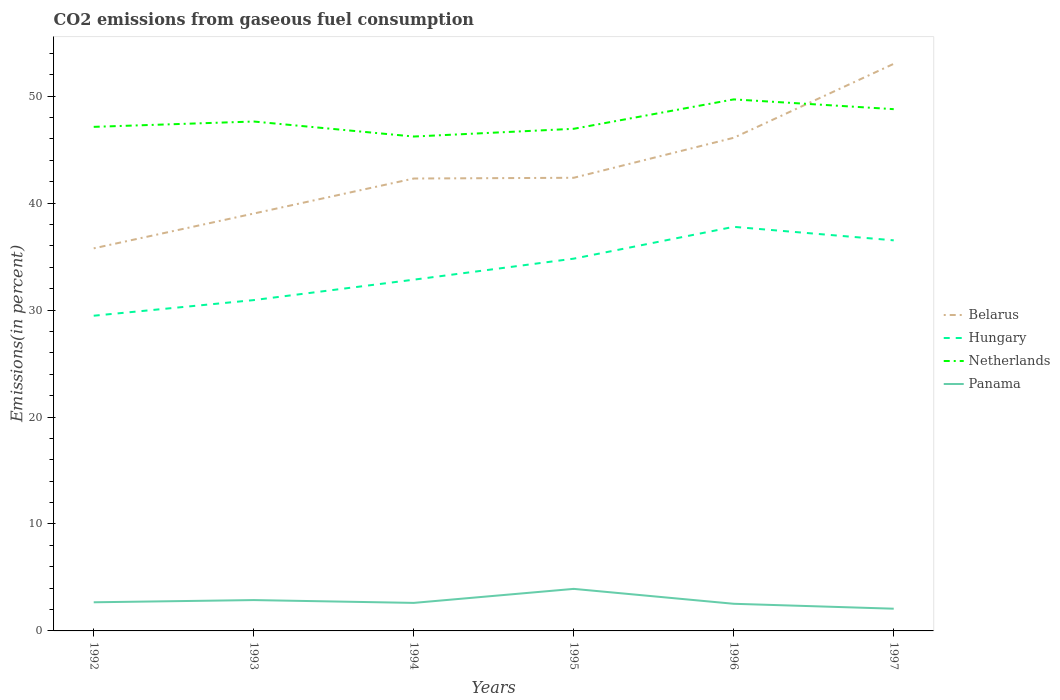How many different coloured lines are there?
Provide a short and direct response. 4. Is the number of lines equal to the number of legend labels?
Ensure brevity in your answer.  Yes. Across all years, what is the maximum total CO2 emitted in Panama?
Ensure brevity in your answer.  2.08. What is the total total CO2 emitted in Hungary in the graph?
Offer a terse response. -2.98. What is the difference between the highest and the second highest total CO2 emitted in Netherlands?
Your answer should be compact. 3.47. How many lines are there?
Keep it short and to the point. 4. What is the title of the graph?
Make the answer very short. CO2 emissions from gaseous fuel consumption. Does "Niger" appear as one of the legend labels in the graph?
Your answer should be very brief. No. What is the label or title of the X-axis?
Offer a very short reply. Years. What is the label or title of the Y-axis?
Offer a terse response. Emissions(in percent). What is the Emissions(in percent) in Belarus in 1992?
Offer a very short reply. 35.77. What is the Emissions(in percent) in Hungary in 1992?
Provide a short and direct response. 29.47. What is the Emissions(in percent) of Netherlands in 1992?
Your answer should be very brief. 47.13. What is the Emissions(in percent) in Panama in 1992?
Provide a succinct answer. 2.68. What is the Emissions(in percent) in Belarus in 1993?
Give a very brief answer. 39.02. What is the Emissions(in percent) of Hungary in 1993?
Make the answer very short. 30.93. What is the Emissions(in percent) of Netherlands in 1993?
Provide a succinct answer. 47.63. What is the Emissions(in percent) of Panama in 1993?
Your answer should be very brief. 2.88. What is the Emissions(in percent) in Belarus in 1994?
Ensure brevity in your answer.  42.3. What is the Emissions(in percent) of Hungary in 1994?
Give a very brief answer. 32.84. What is the Emissions(in percent) in Netherlands in 1994?
Make the answer very short. 46.22. What is the Emissions(in percent) in Panama in 1994?
Give a very brief answer. 2.62. What is the Emissions(in percent) in Belarus in 1995?
Your response must be concise. 42.37. What is the Emissions(in percent) in Hungary in 1995?
Offer a terse response. 34.81. What is the Emissions(in percent) of Netherlands in 1995?
Provide a short and direct response. 46.95. What is the Emissions(in percent) of Panama in 1995?
Make the answer very short. 3.93. What is the Emissions(in percent) in Belarus in 1996?
Give a very brief answer. 46.11. What is the Emissions(in percent) of Hungary in 1996?
Offer a terse response. 37.78. What is the Emissions(in percent) in Netherlands in 1996?
Keep it short and to the point. 49.7. What is the Emissions(in percent) of Panama in 1996?
Keep it short and to the point. 2.54. What is the Emissions(in percent) in Belarus in 1997?
Keep it short and to the point. 53.02. What is the Emissions(in percent) of Hungary in 1997?
Offer a terse response. 36.52. What is the Emissions(in percent) of Netherlands in 1997?
Ensure brevity in your answer.  48.78. What is the Emissions(in percent) of Panama in 1997?
Ensure brevity in your answer.  2.08. Across all years, what is the maximum Emissions(in percent) of Belarus?
Ensure brevity in your answer.  53.02. Across all years, what is the maximum Emissions(in percent) in Hungary?
Provide a succinct answer. 37.78. Across all years, what is the maximum Emissions(in percent) of Netherlands?
Your answer should be compact. 49.7. Across all years, what is the maximum Emissions(in percent) of Panama?
Your answer should be very brief. 3.93. Across all years, what is the minimum Emissions(in percent) of Belarus?
Your answer should be compact. 35.77. Across all years, what is the minimum Emissions(in percent) in Hungary?
Provide a succinct answer. 29.47. Across all years, what is the minimum Emissions(in percent) of Netherlands?
Offer a terse response. 46.22. Across all years, what is the minimum Emissions(in percent) of Panama?
Keep it short and to the point. 2.08. What is the total Emissions(in percent) in Belarus in the graph?
Provide a short and direct response. 258.59. What is the total Emissions(in percent) in Hungary in the graph?
Provide a succinct answer. 202.34. What is the total Emissions(in percent) in Netherlands in the graph?
Provide a succinct answer. 286.41. What is the total Emissions(in percent) in Panama in the graph?
Keep it short and to the point. 16.73. What is the difference between the Emissions(in percent) of Belarus in 1992 and that in 1993?
Make the answer very short. -3.25. What is the difference between the Emissions(in percent) of Hungary in 1992 and that in 1993?
Ensure brevity in your answer.  -1.46. What is the difference between the Emissions(in percent) of Netherlands in 1992 and that in 1993?
Keep it short and to the point. -0.5. What is the difference between the Emissions(in percent) in Panama in 1992 and that in 1993?
Your response must be concise. -0.21. What is the difference between the Emissions(in percent) of Belarus in 1992 and that in 1994?
Provide a short and direct response. -6.53. What is the difference between the Emissions(in percent) in Hungary in 1992 and that in 1994?
Make the answer very short. -3.37. What is the difference between the Emissions(in percent) in Netherlands in 1992 and that in 1994?
Offer a very short reply. 0.9. What is the difference between the Emissions(in percent) in Panama in 1992 and that in 1994?
Provide a succinct answer. 0.06. What is the difference between the Emissions(in percent) of Belarus in 1992 and that in 1995?
Offer a very short reply. -6.6. What is the difference between the Emissions(in percent) of Hungary in 1992 and that in 1995?
Ensure brevity in your answer.  -5.34. What is the difference between the Emissions(in percent) in Netherlands in 1992 and that in 1995?
Offer a terse response. 0.18. What is the difference between the Emissions(in percent) in Panama in 1992 and that in 1995?
Ensure brevity in your answer.  -1.25. What is the difference between the Emissions(in percent) in Belarus in 1992 and that in 1996?
Provide a short and direct response. -10.34. What is the difference between the Emissions(in percent) of Hungary in 1992 and that in 1996?
Keep it short and to the point. -8.31. What is the difference between the Emissions(in percent) of Netherlands in 1992 and that in 1996?
Your answer should be compact. -2.57. What is the difference between the Emissions(in percent) in Panama in 1992 and that in 1996?
Your answer should be compact. 0.14. What is the difference between the Emissions(in percent) in Belarus in 1992 and that in 1997?
Your answer should be very brief. -17.25. What is the difference between the Emissions(in percent) of Hungary in 1992 and that in 1997?
Provide a short and direct response. -7.05. What is the difference between the Emissions(in percent) of Netherlands in 1992 and that in 1997?
Your answer should be compact. -1.66. What is the difference between the Emissions(in percent) in Panama in 1992 and that in 1997?
Make the answer very short. 0.6. What is the difference between the Emissions(in percent) in Belarus in 1993 and that in 1994?
Give a very brief answer. -3.27. What is the difference between the Emissions(in percent) of Hungary in 1993 and that in 1994?
Your response must be concise. -1.91. What is the difference between the Emissions(in percent) of Netherlands in 1993 and that in 1994?
Keep it short and to the point. 1.4. What is the difference between the Emissions(in percent) in Panama in 1993 and that in 1994?
Your answer should be very brief. 0.26. What is the difference between the Emissions(in percent) in Belarus in 1993 and that in 1995?
Ensure brevity in your answer.  -3.34. What is the difference between the Emissions(in percent) in Hungary in 1993 and that in 1995?
Provide a succinct answer. -3.87. What is the difference between the Emissions(in percent) of Netherlands in 1993 and that in 1995?
Offer a very short reply. 0.68. What is the difference between the Emissions(in percent) of Panama in 1993 and that in 1995?
Make the answer very short. -1.05. What is the difference between the Emissions(in percent) in Belarus in 1993 and that in 1996?
Your answer should be compact. -7.08. What is the difference between the Emissions(in percent) of Hungary in 1993 and that in 1996?
Provide a succinct answer. -6.85. What is the difference between the Emissions(in percent) in Netherlands in 1993 and that in 1996?
Keep it short and to the point. -2.07. What is the difference between the Emissions(in percent) of Panama in 1993 and that in 1996?
Your answer should be very brief. 0.35. What is the difference between the Emissions(in percent) of Belarus in 1993 and that in 1997?
Offer a terse response. -14. What is the difference between the Emissions(in percent) of Hungary in 1993 and that in 1997?
Your answer should be compact. -5.59. What is the difference between the Emissions(in percent) of Netherlands in 1993 and that in 1997?
Offer a terse response. -1.16. What is the difference between the Emissions(in percent) of Panama in 1993 and that in 1997?
Keep it short and to the point. 0.81. What is the difference between the Emissions(in percent) of Belarus in 1994 and that in 1995?
Give a very brief answer. -0.07. What is the difference between the Emissions(in percent) of Hungary in 1994 and that in 1995?
Make the answer very short. -1.97. What is the difference between the Emissions(in percent) of Netherlands in 1994 and that in 1995?
Ensure brevity in your answer.  -0.72. What is the difference between the Emissions(in percent) in Panama in 1994 and that in 1995?
Offer a very short reply. -1.31. What is the difference between the Emissions(in percent) in Belarus in 1994 and that in 1996?
Offer a terse response. -3.81. What is the difference between the Emissions(in percent) of Hungary in 1994 and that in 1996?
Keep it short and to the point. -4.94. What is the difference between the Emissions(in percent) of Netherlands in 1994 and that in 1996?
Provide a succinct answer. -3.47. What is the difference between the Emissions(in percent) in Panama in 1994 and that in 1996?
Ensure brevity in your answer.  0.08. What is the difference between the Emissions(in percent) in Belarus in 1994 and that in 1997?
Make the answer very short. -10.72. What is the difference between the Emissions(in percent) in Hungary in 1994 and that in 1997?
Provide a succinct answer. -3.68. What is the difference between the Emissions(in percent) of Netherlands in 1994 and that in 1997?
Offer a terse response. -2.56. What is the difference between the Emissions(in percent) in Panama in 1994 and that in 1997?
Your answer should be very brief. 0.54. What is the difference between the Emissions(in percent) in Belarus in 1995 and that in 1996?
Offer a very short reply. -3.74. What is the difference between the Emissions(in percent) in Hungary in 1995 and that in 1996?
Give a very brief answer. -2.98. What is the difference between the Emissions(in percent) of Netherlands in 1995 and that in 1996?
Make the answer very short. -2.75. What is the difference between the Emissions(in percent) of Panama in 1995 and that in 1996?
Offer a very short reply. 1.39. What is the difference between the Emissions(in percent) in Belarus in 1995 and that in 1997?
Provide a short and direct response. -10.65. What is the difference between the Emissions(in percent) in Hungary in 1995 and that in 1997?
Offer a very short reply. -1.71. What is the difference between the Emissions(in percent) in Netherlands in 1995 and that in 1997?
Your answer should be compact. -1.84. What is the difference between the Emissions(in percent) in Panama in 1995 and that in 1997?
Offer a very short reply. 1.85. What is the difference between the Emissions(in percent) in Belarus in 1996 and that in 1997?
Your response must be concise. -6.91. What is the difference between the Emissions(in percent) of Hungary in 1996 and that in 1997?
Your response must be concise. 1.26. What is the difference between the Emissions(in percent) of Netherlands in 1996 and that in 1997?
Provide a succinct answer. 0.91. What is the difference between the Emissions(in percent) in Panama in 1996 and that in 1997?
Your response must be concise. 0.46. What is the difference between the Emissions(in percent) in Belarus in 1992 and the Emissions(in percent) in Hungary in 1993?
Offer a terse response. 4.84. What is the difference between the Emissions(in percent) in Belarus in 1992 and the Emissions(in percent) in Netherlands in 1993?
Ensure brevity in your answer.  -11.86. What is the difference between the Emissions(in percent) in Belarus in 1992 and the Emissions(in percent) in Panama in 1993?
Your answer should be very brief. 32.89. What is the difference between the Emissions(in percent) of Hungary in 1992 and the Emissions(in percent) of Netherlands in 1993?
Make the answer very short. -18.16. What is the difference between the Emissions(in percent) in Hungary in 1992 and the Emissions(in percent) in Panama in 1993?
Your answer should be very brief. 26.59. What is the difference between the Emissions(in percent) in Netherlands in 1992 and the Emissions(in percent) in Panama in 1993?
Provide a short and direct response. 44.24. What is the difference between the Emissions(in percent) in Belarus in 1992 and the Emissions(in percent) in Hungary in 1994?
Make the answer very short. 2.93. What is the difference between the Emissions(in percent) in Belarus in 1992 and the Emissions(in percent) in Netherlands in 1994?
Provide a succinct answer. -10.45. What is the difference between the Emissions(in percent) of Belarus in 1992 and the Emissions(in percent) of Panama in 1994?
Give a very brief answer. 33.15. What is the difference between the Emissions(in percent) of Hungary in 1992 and the Emissions(in percent) of Netherlands in 1994?
Give a very brief answer. -16.75. What is the difference between the Emissions(in percent) in Hungary in 1992 and the Emissions(in percent) in Panama in 1994?
Provide a short and direct response. 26.85. What is the difference between the Emissions(in percent) in Netherlands in 1992 and the Emissions(in percent) in Panama in 1994?
Offer a very short reply. 44.51. What is the difference between the Emissions(in percent) of Belarus in 1992 and the Emissions(in percent) of Hungary in 1995?
Ensure brevity in your answer.  0.96. What is the difference between the Emissions(in percent) in Belarus in 1992 and the Emissions(in percent) in Netherlands in 1995?
Offer a very short reply. -11.18. What is the difference between the Emissions(in percent) in Belarus in 1992 and the Emissions(in percent) in Panama in 1995?
Your answer should be compact. 31.84. What is the difference between the Emissions(in percent) in Hungary in 1992 and the Emissions(in percent) in Netherlands in 1995?
Make the answer very short. -17.48. What is the difference between the Emissions(in percent) of Hungary in 1992 and the Emissions(in percent) of Panama in 1995?
Ensure brevity in your answer.  25.54. What is the difference between the Emissions(in percent) in Netherlands in 1992 and the Emissions(in percent) in Panama in 1995?
Provide a succinct answer. 43.2. What is the difference between the Emissions(in percent) of Belarus in 1992 and the Emissions(in percent) of Hungary in 1996?
Offer a very short reply. -2.01. What is the difference between the Emissions(in percent) in Belarus in 1992 and the Emissions(in percent) in Netherlands in 1996?
Make the answer very short. -13.93. What is the difference between the Emissions(in percent) in Belarus in 1992 and the Emissions(in percent) in Panama in 1996?
Provide a succinct answer. 33.23. What is the difference between the Emissions(in percent) in Hungary in 1992 and the Emissions(in percent) in Netherlands in 1996?
Give a very brief answer. -20.23. What is the difference between the Emissions(in percent) in Hungary in 1992 and the Emissions(in percent) in Panama in 1996?
Give a very brief answer. 26.93. What is the difference between the Emissions(in percent) in Netherlands in 1992 and the Emissions(in percent) in Panama in 1996?
Your response must be concise. 44.59. What is the difference between the Emissions(in percent) of Belarus in 1992 and the Emissions(in percent) of Hungary in 1997?
Your answer should be compact. -0.75. What is the difference between the Emissions(in percent) of Belarus in 1992 and the Emissions(in percent) of Netherlands in 1997?
Offer a terse response. -13.01. What is the difference between the Emissions(in percent) of Belarus in 1992 and the Emissions(in percent) of Panama in 1997?
Your answer should be very brief. 33.69. What is the difference between the Emissions(in percent) in Hungary in 1992 and the Emissions(in percent) in Netherlands in 1997?
Provide a succinct answer. -19.31. What is the difference between the Emissions(in percent) of Hungary in 1992 and the Emissions(in percent) of Panama in 1997?
Keep it short and to the point. 27.39. What is the difference between the Emissions(in percent) in Netherlands in 1992 and the Emissions(in percent) in Panama in 1997?
Your response must be concise. 45.05. What is the difference between the Emissions(in percent) in Belarus in 1993 and the Emissions(in percent) in Hungary in 1994?
Offer a terse response. 6.18. What is the difference between the Emissions(in percent) in Belarus in 1993 and the Emissions(in percent) in Netherlands in 1994?
Offer a terse response. -7.2. What is the difference between the Emissions(in percent) of Belarus in 1993 and the Emissions(in percent) of Panama in 1994?
Provide a short and direct response. 36.4. What is the difference between the Emissions(in percent) in Hungary in 1993 and the Emissions(in percent) in Netherlands in 1994?
Keep it short and to the point. -15.29. What is the difference between the Emissions(in percent) in Hungary in 1993 and the Emissions(in percent) in Panama in 1994?
Keep it short and to the point. 28.31. What is the difference between the Emissions(in percent) of Netherlands in 1993 and the Emissions(in percent) of Panama in 1994?
Keep it short and to the point. 45.01. What is the difference between the Emissions(in percent) in Belarus in 1993 and the Emissions(in percent) in Hungary in 1995?
Your answer should be very brief. 4.22. What is the difference between the Emissions(in percent) in Belarus in 1993 and the Emissions(in percent) in Netherlands in 1995?
Your answer should be compact. -7.92. What is the difference between the Emissions(in percent) in Belarus in 1993 and the Emissions(in percent) in Panama in 1995?
Keep it short and to the point. 35.09. What is the difference between the Emissions(in percent) in Hungary in 1993 and the Emissions(in percent) in Netherlands in 1995?
Your answer should be very brief. -16.02. What is the difference between the Emissions(in percent) in Hungary in 1993 and the Emissions(in percent) in Panama in 1995?
Your answer should be compact. 27. What is the difference between the Emissions(in percent) in Netherlands in 1993 and the Emissions(in percent) in Panama in 1995?
Make the answer very short. 43.7. What is the difference between the Emissions(in percent) of Belarus in 1993 and the Emissions(in percent) of Hungary in 1996?
Your response must be concise. 1.24. What is the difference between the Emissions(in percent) of Belarus in 1993 and the Emissions(in percent) of Netherlands in 1996?
Offer a very short reply. -10.67. What is the difference between the Emissions(in percent) in Belarus in 1993 and the Emissions(in percent) in Panama in 1996?
Provide a short and direct response. 36.49. What is the difference between the Emissions(in percent) of Hungary in 1993 and the Emissions(in percent) of Netherlands in 1996?
Offer a very short reply. -18.77. What is the difference between the Emissions(in percent) of Hungary in 1993 and the Emissions(in percent) of Panama in 1996?
Your answer should be compact. 28.39. What is the difference between the Emissions(in percent) in Netherlands in 1993 and the Emissions(in percent) in Panama in 1996?
Your answer should be compact. 45.09. What is the difference between the Emissions(in percent) in Belarus in 1993 and the Emissions(in percent) in Hungary in 1997?
Your answer should be very brief. 2.5. What is the difference between the Emissions(in percent) of Belarus in 1993 and the Emissions(in percent) of Netherlands in 1997?
Offer a very short reply. -9.76. What is the difference between the Emissions(in percent) in Belarus in 1993 and the Emissions(in percent) in Panama in 1997?
Make the answer very short. 36.95. What is the difference between the Emissions(in percent) of Hungary in 1993 and the Emissions(in percent) of Netherlands in 1997?
Provide a short and direct response. -17.85. What is the difference between the Emissions(in percent) of Hungary in 1993 and the Emissions(in percent) of Panama in 1997?
Provide a short and direct response. 28.85. What is the difference between the Emissions(in percent) of Netherlands in 1993 and the Emissions(in percent) of Panama in 1997?
Provide a succinct answer. 45.55. What is the difference between the Emissions(in percent) of Belarus in 1994 and the Emissions(in percent) of Hungary in 1995?
Provide a succinct answer. 7.49. What is the difference between the Emissions(in percent) in Belarus in 1994 and the Emissions(in percent) in Netherlands in 1995?
Offer a very short reply. -4.65. What is the difference between the Emissions(in percent) of Belarus in 1994 and the Emissions(in percent) of Panama in 1995?
Your answer should be very brief. 38.37. What is the difference between the Emissions(in percent) in Hungary in 1994 and the Emissions(in percent) in Netherlands in 1995?
Give a very brief answer. -14.11. What is the difference between the Emissions(in percent) of Hungary in 1994 and the Emissions(in percent) of Panama in 1995?
Provide a succinct answer. 28.91. What is the difference between the Emissions(in percent) in Netherlands in 1994 and the Emissions(in percent) in Panama in 1995?
Provide a short and direct response. 42.29. What is the difference between the Emissions(in percent) in Belarus in 1994 and the Emissions(in percent) in Hungary in 1996?
Provide a short and direct response. 4.52. What is the difference between the Emissions(in percent) of Belarus in 1994 and the Emissions(in percent) of Netherlands in 1996?
Make the answer very short. -7.4. What is the difference between the Emissions(in percent) in Belarus in 1994 and the Emissions(in percent) in Panama in 1996?
Offer a terse response. 39.76. What is the difference between the Emissions(in percent) in Hungary in 1994 and the Emissions(in percent) in Netherlands in 1996?
Your answer should be compact. -16.86. What is the difference between the Emissions(in percent) of Hungary in 1994 and the Emissions(in percent) of Panama in 1996?
Give a very brief answer. 30.3. What is the difference between the Emissions(in percent) of Netherlands in 1994 and the Emissions(in percent) of Panama in 1996?
Your response must be concise. 43.69. What is the difference between the Emissions(in percent) in Belarus in 1994 and the Emissions(in percent) in Hungary in 1997?
Provide a short and direct response. 5.78. What is the difference between the Emissions(in percent) in Belarus in 1994 and the Emissions(in percent) in Netherlands in 1997?
Offer a terse response. -6.49. What is the difference between the Emissions(in percent) in Belarus in 1994 and the Emissions(in percent) in Panama in 1997?
Keep it short and to the point. 40.22. What is the difference between the Emissions(in percent) of Hungary in 1994 and the Emissions(in percent) of Netherlands in 1997?
Your answer should be very brief. -15.94. What is the difference between the Emissions(in percent) of Hungary in 1994 and the Emissions(in percent) of Panama in 1997?
Your answer should be very brief. 30.76. What is the difference between the Emissions(in percent) of Netherlands in 1994 and the Emissions(in percent) of Panama in 1997?
Your answer should be very brief. 44.15. What is the difference between the Emissions(in percent) of Belarus in 1995 and the Emissions(in percent) of Hungary in 1996?
Offer a terse response. 4.59. What is the difference between the Emissions(in percent) of Belarus in 1995 and the Emissions(in percent) of Netherlands in 1996?
Ensure brevity in your answer.  -7.33. What is the difference between the Emissions(in percent) in Belarus in 1995 and the Emissions(in percent) in Panama in 1996?
Provide a short and direct response. 39.83. What is the difference between the Emissions(in percent) of Hungary in 1995 and the Emissions(in percent) of Netherlands in 1996?
Give a very brief answer. -14.89. What is the difference between the Emissions(in percent) of Hungary in 1995 and the Emissions(in percent) of Panama in 1996?
Provide a short and direct response. 32.27. What is the difference between the Emissions(in percent) in Netherlands in 1995 and the Emissions(in percent) in Panama in 1996?
Provide a succinct answer. 44.41. What is the difference between the Emissions(in percent) of Belarus in 1995 and the Emissions(in percent) of Hungary in 1997?
Ensure brevity in your answer.  5.85. What is the difference between the Emissions(in percent) in Belarus in 1995 and the Emissions(in percent) in Netherlands in 1997?
Provide a short and direct response. -6.42. What is the difference between the Emissions(in percent) in Belarus in 1995 and the Emissions(in percent) in Panama in 1997?
Provide a succinct answer. 40.29. What is the difference between the Emissions(in percent) of Hungary in 1995 and the Emissions(in percent) of Netherlands in 1997?
Give a very brief answer. -13.98. What is the difference between the Emissions(in percent) of Hungary in 1995 and the Emissions(in percent) of Panama in 1997?
Offer a very short reply. 32.73. What is the difference between the Emissions(in percent) of Netherlands in 1995 and the Emissions(in percent) of Panama in 1997?
Offer a very short reply. 44.87. What is the difference between the Emissions(in percent) in Belarus in 1996 and the Emissions(in percent) in Hungary in 1997?
Give a very brief answer. 9.59. What is the difference between the Emissions(in percent) in Belarus in 1996 and the Emissions(in percent) in Netherlands in 1997?
Ensure brevity in your answer.  -2.68. What is the difference between the Emissions(in percent) of Belarus in 1996 and the Emissions(in percent) of Panama in 1997?
Provide a short and direct response. 44.03. What is the difference between the Emissions(in percent) in Hungary in 1996 and the Emissions(in percent) in Netherlands in 1997?
Keep it short and to the point. -11. What is the difference between the Emissions(in percent) of Hungary in 1996 and the Emissions(in percent) of Panama in 1997?
Provide a succinct answer. 35.7. What is the difference between the Emissions(in percent) of Netherlands in 1996 and the Emissions(in percent) of Panama in 1997?
Your response must be concise. 47.62. What is the average Emissions(in percent) of Belarus per year?
Offer a very short reply. 43.1. What is the average Emissions(in percent) in Hungary per year?
Offer a terse response. 33.72. What is the average Emissions(in percent) of Netherlands per year?
Ensure brevity in your answer.  47.73. What is the average Emissions(in percent) of Panama per year?
Your response must be concise. 2.79. In the year 1992, what is the difference between the Emissions(in percent) in Belarus and Emissions(in percent) in Hungary?
Provide a succinct answer. 6.3. In the year 1992, what is the difference between the Emissions(in percent) in Belarus and Emissions(in percent) in Netherlands?
Your response must be concise. -11.36. In the year 1992, what is the difference between the Emissions(in percent) in Belarus and Emissions(in percent) in Panama?
Offer a very short reply. 33.09. In the year 1992, what is the difference between the Emissions(in percent) of Hungary and Emissions(in percent) of Netherlands?
Ensure brevity in your answer.  -17.66. In the year 1992, what is the difference between the Emissions(in percent) in Hungary and Emissions(in percent) in Panama?
Give a very brief answer. 26.79. In the year 1992, what is the difference between the Emissions(in percent) of Netherlands and Emissions(in percent) of Panama?
Your response must be concise. 44.45. In the year 1993, what is the difference between the Emissions(in percent) of Belarus and Emissions(in percent) of Hungary?
Offer a very short reply. 8.09. In the year 1993, what is the difference between the Emissions(in percent) in Belarus and Emissions(in percent) in Netherlands?
Keep it short and to the point. -8.6. In the year 1993, what is the difference between the Emissions(in percent) of Belarus and Emissions(in percent) of Panama?
Offer a terse response. 36.14. In the year 1993, what is the difference between the Emissions(in percent) of Hungary and Emissions(in percent) of Netherlands?
Provide a short and direct response. -16.7. In the year 1993, what is the difference between the Emissions(in percent) of Hungary and Emissions(in percent) of Panama?
Provide a succinct answer. 28.05. In the year 1993, what is the difference between the Emissions(in percent) in Netherlands and Emissions(in percent) in Panama?
Give a very brief answer. 44.74. In the year 1994, what is the difference between the Emissions(in percent) of Belarus and Emissions(in percent) of Hungary?
Keep it short and to the point. 9.46. In the year 1994, what is the difference between the Emissions(in percent) of Belarus and Emissions(in percent) of Netherlands?
Give a very brief answer. -3.93. In the year 1994, what is the difference between the Emissions(in percent) of Belarus and Emissions(in percent) of Panama?
Ensure brevity in your answer.  39.68. In the year 1994, what is the difference between the Emissions(in percent) of Hungary and Emissions(in percent) of Netherlands?
Provide a succinct answer. -13.38. In the year 1994, what is the difference between the Emissions(in percent) of Hungary and Emissions(in percent) of Panama?
Provide a succinct answer. 30.22. In the year 1994, what is the difference between the Emissions(in percent) of Netherlands and Emissions(in percent) of Panama?
Provide a succinct answer. 43.6. In the year 1995, what is the difference between the Emissions(in percent) of Belarus and Emissions(in percent) of Hungary?
Provide a succinct answer. 7.56. In the year 1995, what is the difference between the Emissions(in percent) of Belarus and Emissions(in percent) of Netherlands?
Keep it short and to the point. -4.58. In the year 1995, what is the difference between the Emissions(in percent) of Belarus and Emissions(in percent) of Panama?
Your response must be concise. 38.44. In the year 1995, what is the difference between the Emissions(in percent) in Hungary and Emissions(in percent) in Netherlands?
Ensure brevity in your answer.  -12.14. In the year 1995, what is the difference between the Emissions(in percent) of Hungary and Emissions(in percent) of Panama?
Ensure brevity in your answer.  30.87. In the year 1995, what is the difference between the Emissions(in percent) in Netherlands and Emissions(in percent) in Panama?
Your answer should be compact. 43.02. In the year 1996, what is the difference between the Emissions(in percent) in Belarus and Emissions(in percent) in Hungary?
Give a very brief answer. 8.33. In the year 1996, what is the difference between the Emissions(in percent) in Belarus and Emissions(in percent) in Netherlands?
Keep it short and to the point. -3.59. In the year 1996, what is the difference between the Emissions(in percent) in Belarus and Emissions(in percent) in Panama?
Keep it short and to the point. 43.57. In the year 1996, what is the difference between the Emissions(in percent) in Hungary and Emissions(in percent) in Netherlands?
Your response must be concise. -11.92. In the year 1996, what is the difference between the Emissions(in percent) in Hungary and Emissions(in percent) in Panama?
Offer a very short reply. 35.24. In the year 1996, what is the difference between the Emissions(in percent) of Netherlands and Emissions(in percent) of Panama?
Your response must be concise. 47.16. In the year 1997, what is the difference between the Emissions(in percent) in Belarus and Emissions(in percent) in Hungary?
Offer a very short reply. 16.5. In the year 1997, what is the difference between the Emissions(in percent) in Belarus and Emissions(in percent) in Netherlands?
Keep it short and to the point. 4.24. In the year 1997, what is the difference between the Emissions(in percent) in Belarus and Emissions(in percent) in Panama?
Give a very brief answer. 50.94. In the year 1997, what is the difference between the Emissions(in percent) in Hungary and Emissions(in percent) in Netherlands?
Provide a succinct answer. -12.26. In the year 1997, what is the difference between the Emissions(in percent) of Hungary and Emissions(in percent) of Panama?
Make the answer very short. 34.44. In the year 1997, what is the difference between the Emissions(in percent) of Netherlands and Emissions(in percent) of Panama?
Make the answer very short. 46.71. What is the ratio of the Emissions(in percent) of Belarus in 1992 to that in 1993?
Your answer should be very brief. 0.92. What is the ratio of the Emissions(in percent) in Hungary in 1992 to that in 1993?
Offer a terse response. 0.95. What is the ratio of the Emissions(in percent) of Netherlands in 1992 to that in 1993?
Offer a terse response. 0.99. What is the ratio of the Emissions(in percent) in Panama in 1992 to that in 1993?
Provide a short and direct response. 0.93. What is the ratio of the Emissions(in percent) of Belarus in 1992 to that in 1994?
Your response must be concise. 0.85. What is the ratio of the Emissions(in percent) in Hungary in 1992 to that in 1994?
Your answer should be very brief. 0.9. What is the ratio of the Emissions(in percent) in Netherlands in 1992 to that in 1994?
Give a very brief answer. 1.02. What is the ratio of the Emissions(in percent) in Panama in 1992 to that in 1994?
Ensure brevity in your answer.  1.02. What is the ratio of the Emissions(in percent) of Belarus in 1992 to that in 1995?
Provide a short and direct response. 0.84. What is the ratio of the Emissions(in percent) in Hungary in 1992 to that in 1995?
Your answer should be very brief. 0.85. What is the ratio of the Emissions(in percent) in Panama in 1992 to that in 1995?
Offer a very short reply. 0.68. What is the ratio of the Emissions(in percent) of Belarus in 1992 to that in 1996?
Offer a very short reply. 0.78. What is the ratio of the Emissions(in percent) of Hungary in 1992 to that in 1996?
Offer a terse response. 0.78. What is the ratio of the Emissions(in percent) in Netherlands in 1992 to that in 1996?
Provide a succinct answer. 0.95. What is the ratio of the Emissions(in percent) of Panama in 1992 to that in 1996?
Ensure brevity in your answer.  1.05. What is the ratio of the Emissions(in percent) of Belarus in 1992 to that in 1997?
Your answer should be compact. 0.67. What is the ratio of the Emissions(in percent) in Hungary in 1992 to that in 1997?
Keep it short and to the point. 0.81. What is the ratio of the Emissions(in percent) of Netherlands in 1992 to that in 1997?
Your answer should be very brief. 0.97. What is the ratio of the Emissions(in percent) of Panama in 1992 to that in 1997?
Provide a succinct answer. 1.29. What is the ratio of the Emissions(in percent) of Belarus in 1993 to that in 1994?
Your response must be concise. 0.92. What is the ratio of the Emissions(in percent) in Hungary in 1993 to that in 1994?
Keep it short and to the point. 0.94. What is the ratio of the Emissions(in percent) in Netherlands in 1993 to that in 1994?
Give a very brief answer. 1.03. What is the ratio of the Emissions(in percent) in Panama in 1993 to that in 1994?
Keep it short and to the point. 1.1. What is the ratio of the Emissions(in percent) of Belarus in 1993 to that in 1995?
Ensure brevity in your answer.  0.92. What is the ratio of the Emissions(in percent) in Hungary in 1993 to that in 1995?
Provide a succinct answer. 0.89. What is the ratio of the Emissions(in percent) in Netherlands in 1993 to that in 1995?
Give a very brief answer. 1.01. What is the ratio of the Emissions(in percent) in Panama in 1993 to that in 1995?
Your answer should be very brief. 0.73. What is the ratio of the Emissions(in percent) of Belarus in 1993 to that in 1996?
Provide a succinct answer. 0.85. What is the ratio of the Emissions(in percent) in Hungary in 1993 to that in 1996?
Ensure brevity in your answer.  0.82. What is the ratio of the Emissions(in percent) in Netherlands in 1993 to that in 1996?
Your answer should be very brief. 0.96. What is the ratio of the Emissions(in percent) in Panama in 1993 to that in 1996?
Provide a short and direct response. 1.14. What is the ratio of the Emissions(in percent) of Belarus in 1993 to that in 1997?
Make the answer very short. 0.74. What is the ratio of the Emissions(in percent) in Hungary in 1993 to that in 1997?
Ensure brevity in your answer.  0.85. What is the ratio of the Emissions(in percent) of Netherlands in 1993 to that in 1997?
Ensure brevity in your answer.  0.98. What is the ratio of the Emissions(in percent) in Panama in 1993 to that in 1997?
Offer a very short reply. 1.39. What is the ratio of the Emissions(in percent) of Belarus in 1994 to that in 1995?
Offer a very short reply. 1. What is the ratio of the Emissions(in percent) in Hungary in 1994 to that in 1995?
Provide a short and direct response. 0.94. What is the ratio of the Emissions(in percent) in Netherlands in 1994 to that in 1995?
Provide a succinct answer. 0.98. What is the ratio of the Emissions(in percent) of Panama in 1994 to that in 1995?
Your response must be concise. 0.67. What is the ratio of the Emissions(in percent) of Belarus in 1994 to that in 1996?
Offer a very short reply. 0.92. What is the ratio of the Emissions(in percent) of Hungary in 1994 to that in 1996?
Give a very brief answer. 0.87. What is the ratio of the Emissions(in percent) of Netherlands in 1994 to that in 1996?
Make the answer very short. 0.93. What is the ratio of the Emissions(in percent) in Panama in 1994 to that in 1996?
Keep it short and to the point. 1.03. What is the ratio of the Emissions(in percent) of Belarus in 1994 to that in 1997?
Your response must be concise. 0.8. What is the ratio of the Emissions(in percent) of Hungary in 1994 to that in 1997?
Make the answer very short. 0.9. What is the ratio of the Emissions(in percent) of Netherlands in 1994 to that in 1997?
Your answer should be compact. 0.95. What is the ratio of the Emissions(in percent) in Panama in 1994 to that in 1997?
Offer a very short reply. 1.26. What is the ratio of the Emissions(in percent) in Belarus in 1995 to that in 1996?
Provide a succinct answer. 0.92. What is the ratio of the Emissions(in percent) of Hungary in 1995 to that in 1996?
Keep it short and to the point. 0.92. What is the ratio of the Emissions(in percent) in Netherlands in 1995 to that in 1996?
Give a very brief answer. 0.94. What is the ratio of the Emissions(in percent) in Panama in 1995 to that in 1996?
Ensure brevity in your answer.  1.55. What is the ratio of the Emissions(in percent) of Belarus in 1995 to that in 1997?
Offer a terse response. 0.8. What is the ratio of the Emissions(in percent) in Hungary in 1995 to that in 1997?
Make the answer very short. 0.95. What is the ratio of the Emissions(in percent) in Netherlands in 1995 to that in 1997?
Give a very brief answer. 0.96. What is the ratio of the Emissions(in percent) of Panama in 1995 to that in 1997?
Provide a short and direct response. 1.89. What is the ratio of the Emissions(in percent) in Belarus in 1996 to that in 1997?
Offer a terse response. 0.87. What is the ratio of the Emissions(in percent) in Hungary in 1996 to that in 1997?
Ensure brevity in your answer.  1.03. What is the ratio of the Emissions(in percent) in Netherlands in 1996 to that in 1997?
Make the answer very short. 1.02. What is the ratio of the Emissions(in percent) in Panama in 1996 to that in 1997?
Make the answer very short. 1.22. What is the difference between the highest and the second highest Emissions(in percent) in Belarus?
Ensure brevity in your answer.  6.91. What is the difference between the highest and the second highest Emissions(in percent) in Hungary?
Give a very brief answer. 1.26. What is the difference between the highest and the second highest Emissions(in percent) in Netherlands?
Make the answer very short. 0.91. What is the difference between the highest and the second highest Emissions(in percent) of Panama?
Your answer should be compact. 1.05. What is the difference between the highest and the lowest Emissions(in percent) of Belarus?
Your response must be concise. 17.25. What is the difference between the highest and the lowest Emissions(in percent) of Hungary?
Offer a terse response. 8.31. What is the difference between the highest and the lowest Emissions(in percent) of Netherlands?
Keep it short and to the point. 3.47. What is the difference between the highest and the lowest Emissions(in percent) in Panama?
Provide a short and direct response. 1.85. 